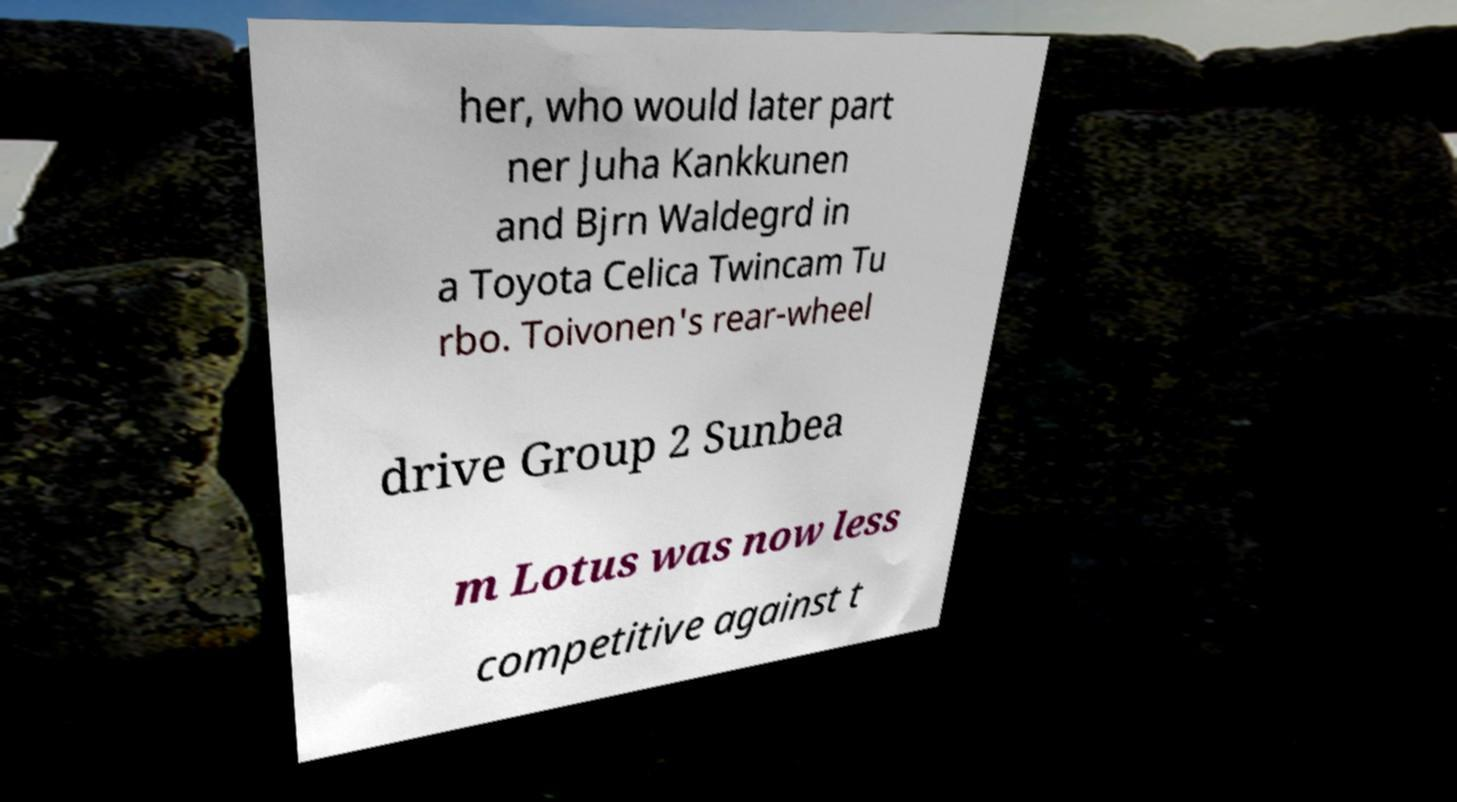Please identify and transcribe the text found in this image. her, who would later part ner Juha Kankkunen and Bjrn Waldegrd in a Toyota Celica Twincam Tu rbo. Toivonen's rear-wheel drive Group 2 Sunbea m Lotus was now less competitive against t 